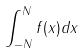Convert formula to latex. <formula><loc_0><loc_0><loc_500><loc_500>\int _ { - N } ^ { N } f ( x ) d x</formula> 